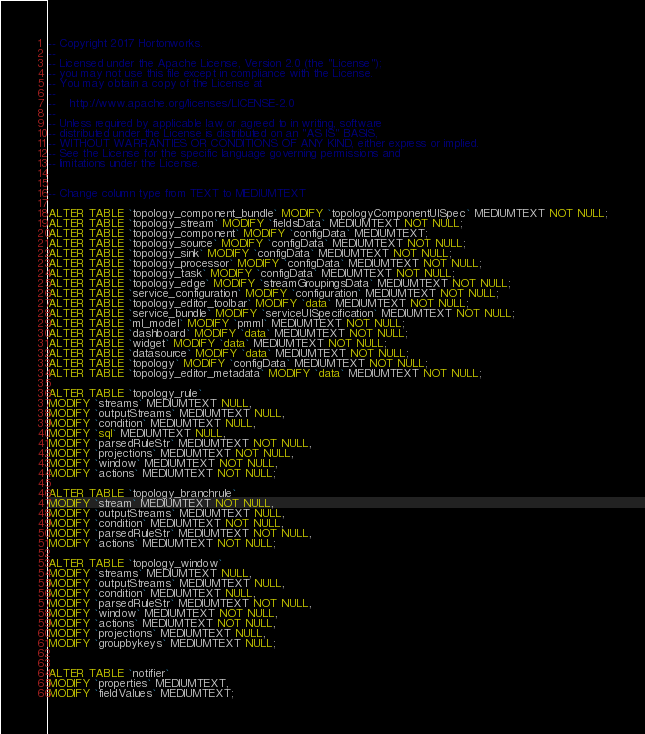Convert code to text. <code><loc_0><loc_0><loc_500><loc_500><_SQL_>-- Copyright 2017 Hortonworks.
--
-- Licensed under the Apache License, Version 2.0 (the "License");
-- you may not use this file except in compliance with the License.
-- You may obtain a copy of the License at
--
--    http://www.apache.org/licenses/LICENSE-2.0
--
-- Unless required by applicable law or agreed to in writing, software
-- distributed under the License is distributed on an "AS IS" BASIS,
-- WITHOUT WARRANTIES OR CONDITIONS OF ANY KIND, either express or implied.
-- See the License for the specific language governing permissions and
-- limitations under the License.


-- Change column type from TEXT to MEDIUMTEXT

ALTER TABLE `topology_component_bundle` MODIFY `topologyComponentUISpec` MEDIUMTEXT NOT NULL;
ALTER TABLE `topology_stream` MODIFY `fieldsData` MEDIUMTEXT NOT NULL;
ALTER TABLE `topology_component` MODIFY `configData` MEDIUMTEXT;
ALTER TABLE `topology_source` MODIFY `configData` MEDIUMTEXT NOT NULL;
ALTER TABLE `topology_sink` MODIFY `configData` MEDIUMTEXT NOT NULL;
ALTER TABLE `topology_processor` MODIFY `configData` MEDIUMTEXT NOT NULL;
ALTER TABLE `topology_task` MODIFY `configData` MEDIUMTEXT NOT NULL;
ALTER TABLE `topology_edge` MODIFY `streamGroupingsData` MEDIUMTEXT NOT NULL;
ALTER TABLE `service_configuration` MODIFY `configuration` MEDIUMTEXT NOT NULL;
ALTER TABLE `topology_editor_toolbar` MODIFY `data` MEDIUMTEXT NOT NULL;
ALTER TABLE `service_bundle` MODIFY `serviceUISpecification` MEDIUMTEXT NOT NULL;
ALTER TABLE `ml_model` MODIFY `pmml` MEDIUMTEXT NOT NULL;
ALTER TABLE `dashboard` MODIFY `data` MEDIUMTEXT NOT NULL;
ALTER TABLE `widget` MODIFY `data` MEDIUMTEXT NOT NULL;
ALTER TABLE `datasource` MODIFY `data` MEDIUMTEXT NOT NULL;
ALTER TABLE `topology` MODIFY `configData` MEDIUMTEXT NOT NULL;
ALTER TABLE `topology_editor_metadata` MODIFY `data` MEDIUMTEXT NOT NULL;

ALTER TABLE `topology_rule`
MODIFY `streams` MEDIUMTEXT NULL,
MODIFY `outputStreams` MEDIUMTEXT NULL,
MODIFY `condition` MEDIUMTEXT NULL,
MODIFY `sql` MEDIUMTEXT NULL,
MODIFY `parsedRuleStr` MEDIUMTEXT NOT NULL,
MODIFY `projections` MEDIUMTEXT NOT NULL,
MODIFY `window` MEDIUMTEXT NOT NULL,
MODIFY `actions` MEDIUMTEXT NOT NULL;

ALTER TABLE `topology_branchrule`
MODIFY `stream` MEDIUMTEXT NOT NULL,
MODIFY `outputStreams` MEDIUMTEXT NULL,
MODIFY `condition` MEDIUMTEXT NOT NULL,
MODIFY `parsedRuleStr` MEDIUMTEXT NOT NULL,
MODIFY `actions` MEDIUMTEXT NOT NULL;

ALTER TABLE `topology_window`
MODIFY `streams` MEDIUMTEXT NULL,
MODIFY `outputStreams` MEDIUMTEXT NULL,
MODIFY `condition` MEDIUMTEXT NULL,
MODIFY `parsedRuleStr` MEDIUMTEXT NOT NULL,
MODIFY `window` MEDIUMTEXT NOT NULL,
MODIFY `actions` MEDIUMTEXT NOT NULL,
MODIFY `projections` MEDIUMTEXT NULL,
MODIFY `groupbykeys` MEDIUMTEXT NULL;


ALTER TABLE `notifier`
MODIFY `properties` MEDIUMTEXT,
MODIFY `fieldValues` MEDIUMTEXT;
</code> 